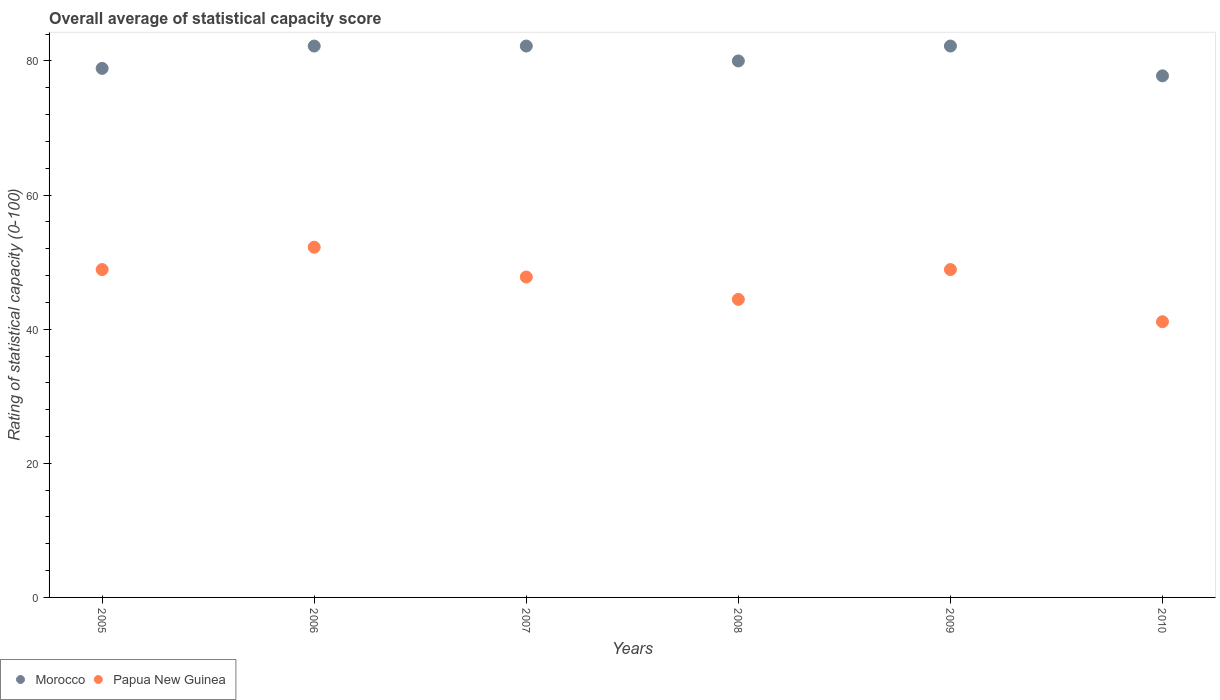Is the number of dotlines equal to the number of legend labels?
Provide a short and direct response. Yes. What is the rating of statistical capacity in Papua New Guinea in 2005?
Your answer should be compact. 48.89. Across all years, what is the maximum rating of statistical capacity in Papua New Guinea?
Your answer should be compact. 52.22. Across all years, what is the minimum rating of statistical capacity in Papua New Guinea?
Offer a terse response. 41.11. In which year was the rating of statistical capacity in Papua New Guinea minimum?
Provide a succinct answer. 2010. What is the total rating of statistical capacity in Morocco in the graph?
Give a very brief answer. 483.33. What is the difference between the rating of statistical capacity in Morocco in 2007 and that in 2009?
Your response must be concise. 0. What is the difference between the rating of statistical capacity in Papua New Guinea in 2006 and the rating of statistical capacity in Morocco in 2009?
Your answer should be compact. -30. What is the average rating of statistical capacity in Morocco per year?
Give a very brief answer. 80.56. In the year 2009, what is the difference between the rating of statistical capacity in Morocco and rating of statistical capacity in Papua New Guinea?
Ensure brevity in your answer.  33.33. What is the ratio of the rating of statistical capacity in Morocco in 2006 to that in 2010?
Provide a short and direct response. 1.06. Is the rating of statistical capacity in Papua New Guinea in 2007 less than that in 2010?
Your answer should be compact. No. Is the difference between the rating of statistical capacity in Morocco in 2007 and 2010 greater than the difference between the rating of statistical capacity in Papua New Guinea in 2007 and 2010?
Offer a very short reply. No. What is the difference between the highest and the second highest rating of statistical capacity in Papua New Guinea?
Make the answer very short. 3.33. What is the difference between the highest and the lowest rating of statistical capacity in Morocco?
Make the answer very short. 4.44. Is the sum of the rating of statistical capacity in Morocco in 2006 and 2009 greater than the maximum rating of statistical capacity in Papua New Guinea across all years?
Offer a terse response. Yes. Is the rating of statistical capacity in Papua New Guinea strictly greater than the rating of statistical capacity in Morocco over the years?
Keep it short and to the point. No. How many dotlines are there?
Your answer should be very brief. 2. How many years are there in the graph?
Ensure brevity in your answer.  6. What is the difference between two consecutive major ticks on the Y-axis?
Give a very brief answer. 20. Does the graph contain grids?
Offer a terse response. No. How many legend labels are there?
Provide a succinct answer. 2. How are the legend labels stacked?
Ensure brevity in your answer.  Horizontal. What is the title of the graph?
Offer a terse response. Overall average of statistical capacity score. What is the label or title of the Y-axis?
Your response must be concise. Rating of statistical capacity (0-100). What is the Rating of statistical capacity (0-100) in Morocco in 2005?
Make the answer very short. 78.89. What is the Rating of statistical capacity (0-100) in Papua New Guinea in 2005?
Make the answer very short. 48.89. What is the Rating of statistical capacity (0-100) of Morocco in 2006?
Your answer should be compact. 82.22. What is the Rating of statistical capacity (0-100) in Papua New Guinea in 2006?
Your answer should be very brief. 52.22. What is the Rating of statistical capacity (0-100) in Morocco in 2007?
Your answer should be very brief. 82.22. What is the Rating of statistical capacity (0-100) of Papua New Guinea in 2007?
Ensure brevity in your answer.  47.78. What is the Rating of statistical capacity (0-100) in Morocco in 2008?
Offer a terse response. 80. What is the Rating of statistical capacity (0-100) of Papua New Guinea in 2008?
Ensure brevity in your answer.  44.44. What is the Rating of statistical capacity (0-100) in Morocco in 2009?
Offer a terse response. 82.22. What is the Rating of statistical capacity (0-100) of Papua New Guinea in 2009?
Your answer should be compact. 48.89. What is the Rating of statistical capacity (0-100) in Morocco in 2010?
Your response must be concise. 77.78. What is the Rating of statistical capacity (0-100) in Papua New Guinea in 2010?
Keep it short and to the point. 41.11. Across all years, what is the maximum Rating of statistical capacity (0-100) of Morocco?
Ensure brevity in your answer.  82.22. Across all years, what is the maximum Rating of statistical capacity (0-100) in Papua New Guinea?
Keep it short and to the point. 52.22. Across all years, what is the minimum Rating of statistical capacity (0-100) in Morocco?
Provide a succinct answer. 77.78. Across all years, what is the minimum Rating of statistical capacity (0-100) in Papua New Guinea?
Ensure brevity in your answer.  41.11. What is the total Rating of statistical capacity (0-100) of Morocco in the graph?
Ensure brevity in your answer.  483.33. What is the total Rating of statistical capacity (0-100) in Papua New Guinea in the graph?
Your answer should be very brief. 283.33. What is the difference between the Rating of statistical capacity (0-100) in Morocco in 2005 and that in 2007?
Provide a succinct answer. -3.33. What is the difference between the Rating of statistical capacity (0-100) in Papua New Guinea in 2005 and that in 2007?
Offer a terse response. 1.11. What is the difference between the Rating of statistical capacity (0-100) in Morocco in 2005 and that in 2008?
Your answer should be very brief. -1.11. What is the difference between the Rating of statistical capacity (0-100) of Papua New Guinea in 2005 and that in 2008?
Your answer should be compact. 4.44. What is the difference between the Rating of statistical capacity (0-100) in Papua New Guinea in 2005 and that in 2010?
Your answer should be very brief. 7.78. What is the difference between the Rating of statistical capacity (0-100) of Papua New Guinea in 2006 and that in 2007?
Offer a terse response. 4.44. What is the difference between the Rating of statistical capacity (0-100) of Morocco in 2006 and that in 2008?
Your answer should be very brief. 2.22. What is the difference between the Rating of statistical capacity (0-100) of Papua New Guinea in 2006 and that in 2008?
Give a very brief answer. 7.78. What is the difference between the Rating of statistical capacity (0-100) of Morocco in 2006 and that in 2010?
Give a very brief answer. 4.44. What is the difference between the Rating of statistical capacity (0-100) in Papua New Guinea in 2006 and that in 2010?
Provide a succinct answer. 11.11. What is the difference between the Rating of statistical capacity (0-100) in Morocco in 2007 and that in 2008?
Your answer should be compact. 2.22. What is the difference between the Rating of statistical capacity (0-100) in Morocco in 2007 and that in 2009?
Offer a very short reply. 0. What is the difference between the Rating of statistical capacity (0-100) in Papua New Guinea in 2007 and that in 2009?
Keep it short and to the point. -1.11. What is the difference between the Rating of statistical capacity (0-100) of Morocco in 2007 and that in 2010?
Provide a short and direct response. 4.44. What is the difference between the Rating of statistical capacity (0-100) of Morocco in 2008 and that in 2009?
Offer a terse response. -2.22. What is the difference between the Rating of statistical capacity (0-100) of Papua New Guinea in 2008 and that in 2009?
Offer a very short reply. -4.44. What is the difference between the Rating of statistical capacity (0-100) in Morocco in 2008 and that in 2010?
Offer a very short reply. 2.22. What is the difference between the Rating of statistical capacity (0-100) in Papua New Guinea in 2008 and that in 2010?
Your answer should be compact. 3.33. What is the difference between the Rating of statistical capacity (0-100) in Morocco in 2009 and that in 2010?
Offer a terse response. 4.44. What is the difference between the Rating of statistical capacity (0-100) in Papua New Guinea in 2009 and that in 2010?
Keep it short and to the point. 7.78. What is the difference between the Rating of statistical capacity (0-100) of Morocco in 2005 and the Rating of statistical capacity (0-100) of Papua New Guinea in 2006?
Give a very brief answer. 26.67. What is the difference between the Rating of statistical capacity (0-100) of Morocco in 2005 and the Rating of statistical capacity (0-100) of Papua New Guinea in 2007?
Keep it short and to the point. 31.11. What is the difference between the Rating of statistical capacity (0-100) of Morocco in 2005 and the Rating of statistical capacity (0-100) of Papua New Guinea in 2008?
Provide a succinct answer. 34.44. What is the difference between the Rating of statistical capacity (0-100) in Morocco in 2005 and the Rating of statistical capacity (0-100) in Papua New Guinea in 2009?
Your response must be concise. 30. What is the difference between the Rating of statistical capacity (0-100) in Morocco in 2005 and the Rating of statistical capacity (0-100) in Papua New Guinea in 2010?
Make the answer very short. 37.78. What is the difference between the Rating of statistical capacity (0-100) in Morocco in 2006 and the Rating of statistical capacity (0-100) in Papua New Guinea in 2007?
Provide a succinct answer. 34.44. What is the difference between the Rating of statistical capacity (0-100) of Morocco in 2006 and the Rating of statistical capacity (0-100) of Papua New Guinea in 2008?
Your response must be concise. 37.78. What is the difference between the Rating of statistical capacity (0-100) in Morocco in 2006 and the Rating of statistical capacity (0-100) in Papua New Guinea in 2009?
Your answer should be compact. 33.33. What is the difference between the Rating of statistical capacity (0-100) of Morocco in 2006 and the Rating of statistical capacity (0-100) of Papua New Guinea in 2010?
Keep it short and to the point. 41.11. What is the difference between the Rating of statistical capacity (0-100) of Morocco in 2007 and the Rating of statistical capacity (0-100) of Papua New Guinea in 2008?
Your response must be concise. 37.78. What is the difference between the Rating of statistical capacity (0-100) of Morocco in 2007 and the Rating of statistical capacity (0-100) of Papua New Guinea in 2009?
Provide a succinct answer. 33.33. What is the difference between the Rating of statistical capacity (0-100) of Morocco in 2007 and the Rating of statistical capacity (0-100) of Papua New Guinea in 2010?
Offer a very short reply. 41.11. What is the difference between the Rating of statistical capacity (0-100) of Morocco in 2008 and the Rating of statistical capacity (0-100) of Papua New Guinea in 2009?
Your response must be concise. 31.11. What is the difference between the Rating of statistical capacity (0-100) of Morocco in 2008 and the Rating of statistical capacity (0-100) of Papua New Guinea in 2010?
Provide a succinct answer. 38.89. What is the difference between the Rating of statistical capacity (0-100) in Morocco in 2009 and the Rating of statistical capacity (0-100) in Papua New Guinea in 2010?
Your answer should be very brief. 41.11. What is the average Rating of statistical capacity (0-100) in Morocco per year?
Provide a short and direct response. 80.56. What is the average Rating of statistical capacity (0-100) in Papua New Guinea per year?
Make the answer very short. 47.22. In the year 2006, what is the difference between the Rating of statistical capacity (0-100) of Morocco and Rating of statistical capacity (0-100) of Papua New Guinea?
Provide a succinct answer. 30. In the year 2007, what is the difference between the Rating of statistical capacity (0-100) in Morocco and Rating of statistical capacity (0-100) in Papua New Guinea?
Give a very brief answer. 34.44. In the year 2008, what is the difference between the Rating of statistical capacity (0-100) of Morocco and Rating of statistical capacity (0-100) of Papua New Guinea?
Ensure brevity in your answer.  35.56. In the year 2009, what is the difference between the Rating of statistical capacity (0-100) of Morocco and Rating of statistical capacity (0-100) of Papua New Guinea?
Your answer should be very brief. 33.33. In the year 2010, what is the difference between the Rating of statistical capacity (0-100) in Morocco and Rating of statistical capacity (0-100) in Papua New Guinea?
Keep it short and to the point. 36.67. What is the ratio of the Rating of statistical capacity (0-100) of Morocco in 2005 to that in 2006?
Provide a short and direct response. 0.96. What is the ratio of the Rating of statistical capacity (0-100) in Papua New Guinea in 2005 to that in 2006?
Offer a very short reply. 0.94. What is the ratio of the Rating of statistical capacity (0-100) in Morocco in 2005 to that in 2007?
Ensure brevity in your answer.  0.96. What is the ratio of the Rating of statistical capacity (0-100) of Papua New Guinea in 2005 to that in 2007?
Keep it short and to the point. 1.02. What is the ratio of the Rating of statistical capacity (0-100) of Morocco in 2005 to that in 2008?
Provide a succinct answer. 0.99. What is the ratio of the Rating of statistical capacity (0-100) in Papua New Guinea in 2005 to that in 2008?
Your response must be concise. 1.1. What is the ratio of the Rating of statistical capacity (0-100) in Morocco in 2005 to that in 2009?
Keep it short and to the point. 0.96. What is the ratio of the Rating of statistical capacity (0-100) in Morocco in 2005 to that in 2010?
Make the answer very short. 1.01. What is the ratio of the Rating of statistical capacity (0-100) in Papua New Guinea in 2005 to that in 2010?
Give a very brief answer. 1.19. What is the ratio of the Rating of statistical capacity (0-100) in Papua New Guinea in 2006 to that in 2007?
Make the answer very short. 1.09. What is the ratio of the Rating of statistical capacity (0-100) of Morocco in 2006 to that in 2008?
Your response must be concise. 1.03. What is the ratio of the Rating of statistical capacity (0-100) of Papua New Guinea in 2006 to that in 2008?
Provide a succinct answer. 1.18. What is the ratio of the Rating of statistical capacity (0-100) of Morocco in 2006 to that in 2009?
Give a very brief answer. 1. What is the ratio of the Rating of statistical capacity (0-100) in Papua New Guinea in 2006 to that in 2009?
Your response must be concise. 1.07. What is the ratio of the Rating of statistical capacity (0-100) of Morocco in 2006 to that in 2010?
Your response must be concise. 1.06. What is the ratio of the Rating of statistical capacity (0-100) of Papua New Guinea in 2006 to that in 2010?
Keep it short and to the point. 1.27. What is the ratio of the Rating of statistical capacity (0-100) in Morocco in 2007 to that in 2008?
Offer a very short reply. 1.03. What is the ratio of the Rating of statistical capacity (0-100) in Papua New Guinea in 2007 to that in 2008?
Your answer should be compact. 1.07. What is the ratio of the Rating of statistical capacity (0-100) of Morocco in 2007 to that in 2009?
Your answer should be very brief. 1. What is the ratio of the Rating of statistical capacity (0-100) in Papua New Guinea in 2007 to that in 2009?
Ensure brevity in your answer.  0.98. What is the ratio of the Rating of statistical capacity (0-100) in Morocco in 2007 to that in 2010?
Keep it short and to the point. 1.06. What is the ratio of the Rating of statistical capacity (0-100) of Papua New Guinea in 2007 to that in 2010?
Your response must be concise. 1.16. What is the ratio of the Rating of statistical capacity (0-100) of Morocco in 2008 to that in 2009?
Offer a very short reply. 0.97. What is the ratio of the Rating of statistical capacity (0-100) of Papua New Guinea in 2008 to that in 2009?
Offer a terse response. 0.91. What is the ratio of the Rating of statistical capacity (0-100) of Morocco in 2008 to that in 2010?
Ensure brevity in your answer.  1.03. What is the ratio of the Rating of statistical capacity (0-100) of Papua New Guinea in 2008 to that in 2010?
Keep it short and to the point. 1.08. What is the ratio of the Rating of statistical capacity (0-100) in Morocco in 2009 to that in 2010?
Your answer should be compact. 1.06. What is the ratio of the Rating of statistical capacity (0-100) of Papua New Guinea in 2009 to that in 2010?
Your answer should be very brief. 1.19. What is the difference between the highest and the second highest Rating of statistical capacity (0-100) of Morocco?
Your answer should be compact. 0. What is the difference between the highest and the lowest Rating of statistical capacity (0-100) in Morocco?
Provide a succinct answer. 4.44. What is the difference between the highest and the lowest Rating of statistical capacity (0-100) in Papua New Guinea?
Make the answer very short. 11.11. 